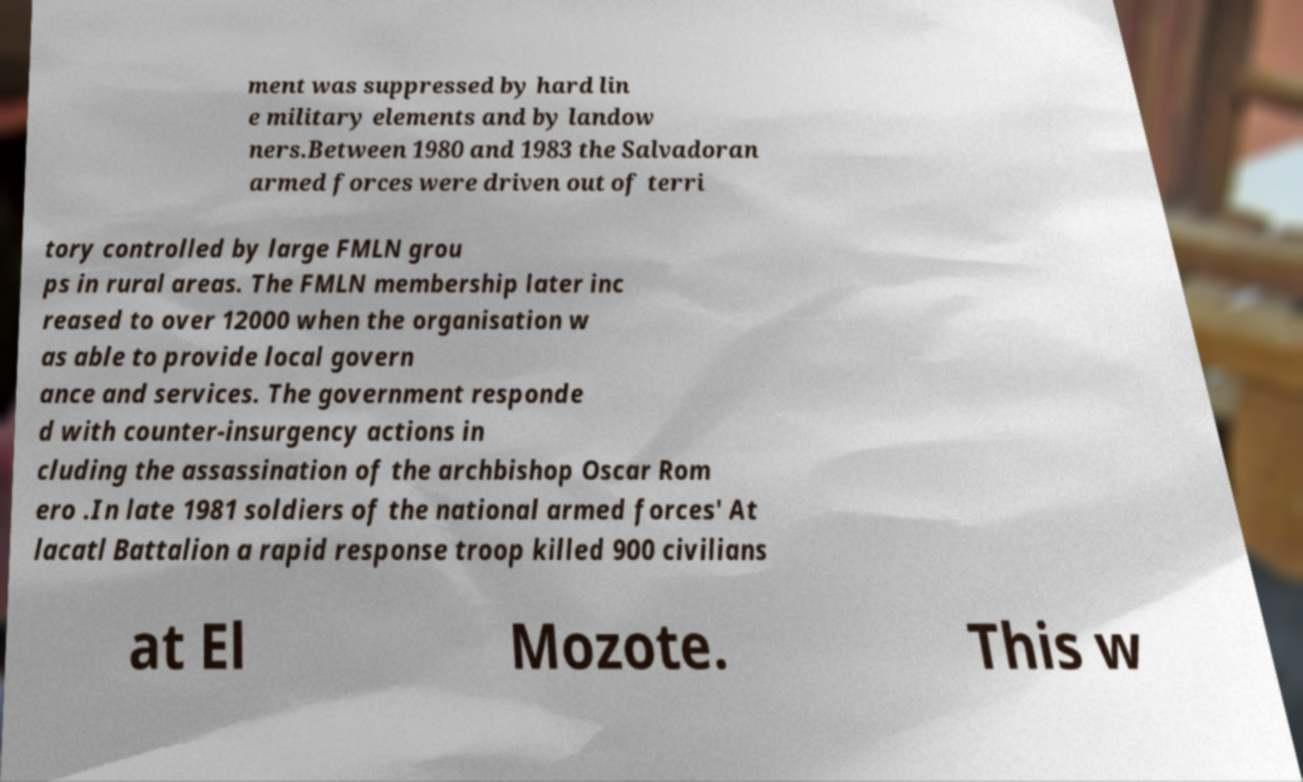Can you read and provide the text displayed in the image?This photo seems to have some interesting text. Can you extract and type it out for me? ment was suppressed by hard lin e military elements and by landow ners.Between 1980 and 1983 the Salvadoran armed forces were driven out of terri tory controlled by large FMLN grou ps in rural areas. The FMLN membership later inc reased to over 12000 when the organisation w as able to provide local govern ance and services. The government responde d with counter-insurgency actions in cluding the assassination of the archbishop Oscar Rom ero .In late 1981 soldiers of the national armed forces' At lacatl Battalion a rapid response troop killed 900 civilians at El Mozote. This w 